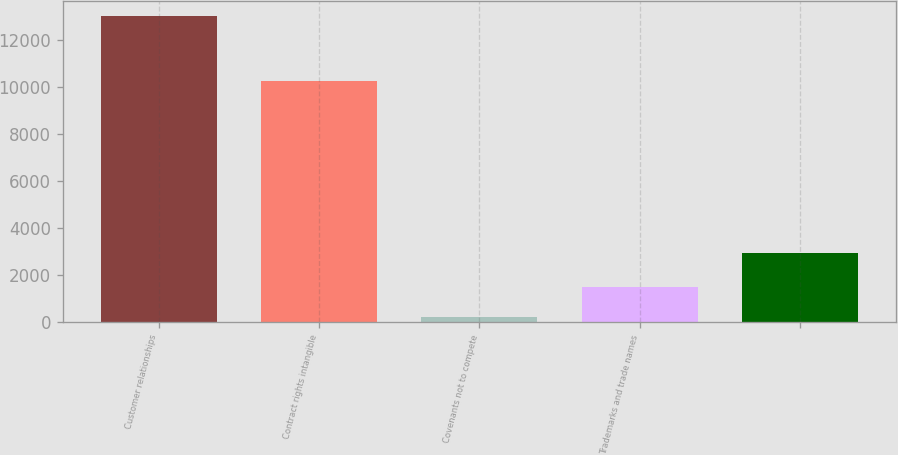<chart> <loc_0><loc_0><loc_500><loc_500><bar_chart><fcel>Customer relationships<fcel>Contract rights intangible<fcel>Covenants not to compete<fcel>Trademarks and trade names<fcel>Unnamed: 4<nl><fcel>13030<fcel>10279<fcel>222<fcel>1502.8<fcel>2964<nl></chart> 